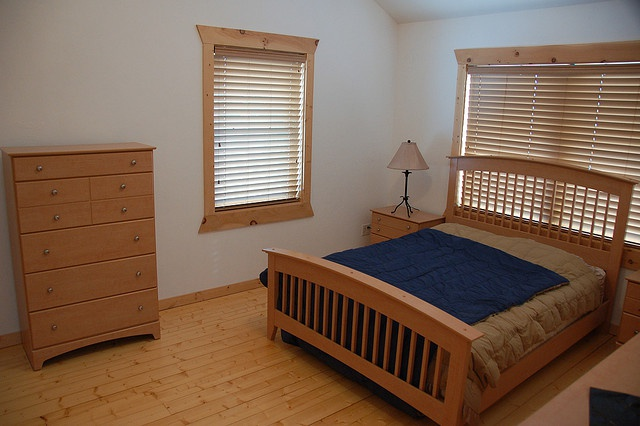Describe the objects in this image and their specific colors. I can see a bed in gray, maroon, and black tones in this image. 